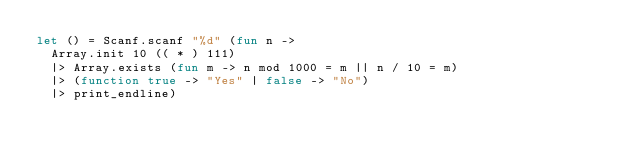<code> <loc_0><loc_0><loc_500><loc_500><_OCaml_>let () = Scanf.scanf "%d" (fun n ->
  Array.init 10 (( * ) 111)
  |> Array.exists (fun m -> n mod 1000 = m || n / 10 = m)
  |> (function true -> "Yes" | false -> "No")
  |> print_endline)</code> 